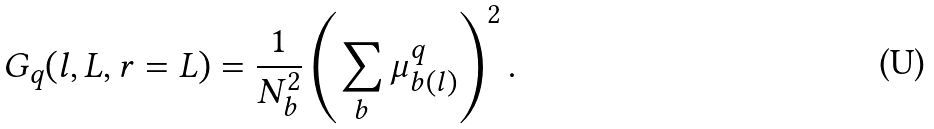Convert formula to latex. <formula><loc_0><loc_0><loc_500><loc_500>G _ { q } ( l , L , r = L ) = \frac { 1 } { N _ { b } ^ { 2 } } \left ( \sum _ { b } \mu _ { b ( l ) } ^ { q } \right ) ^ { 2 } .</formula> 